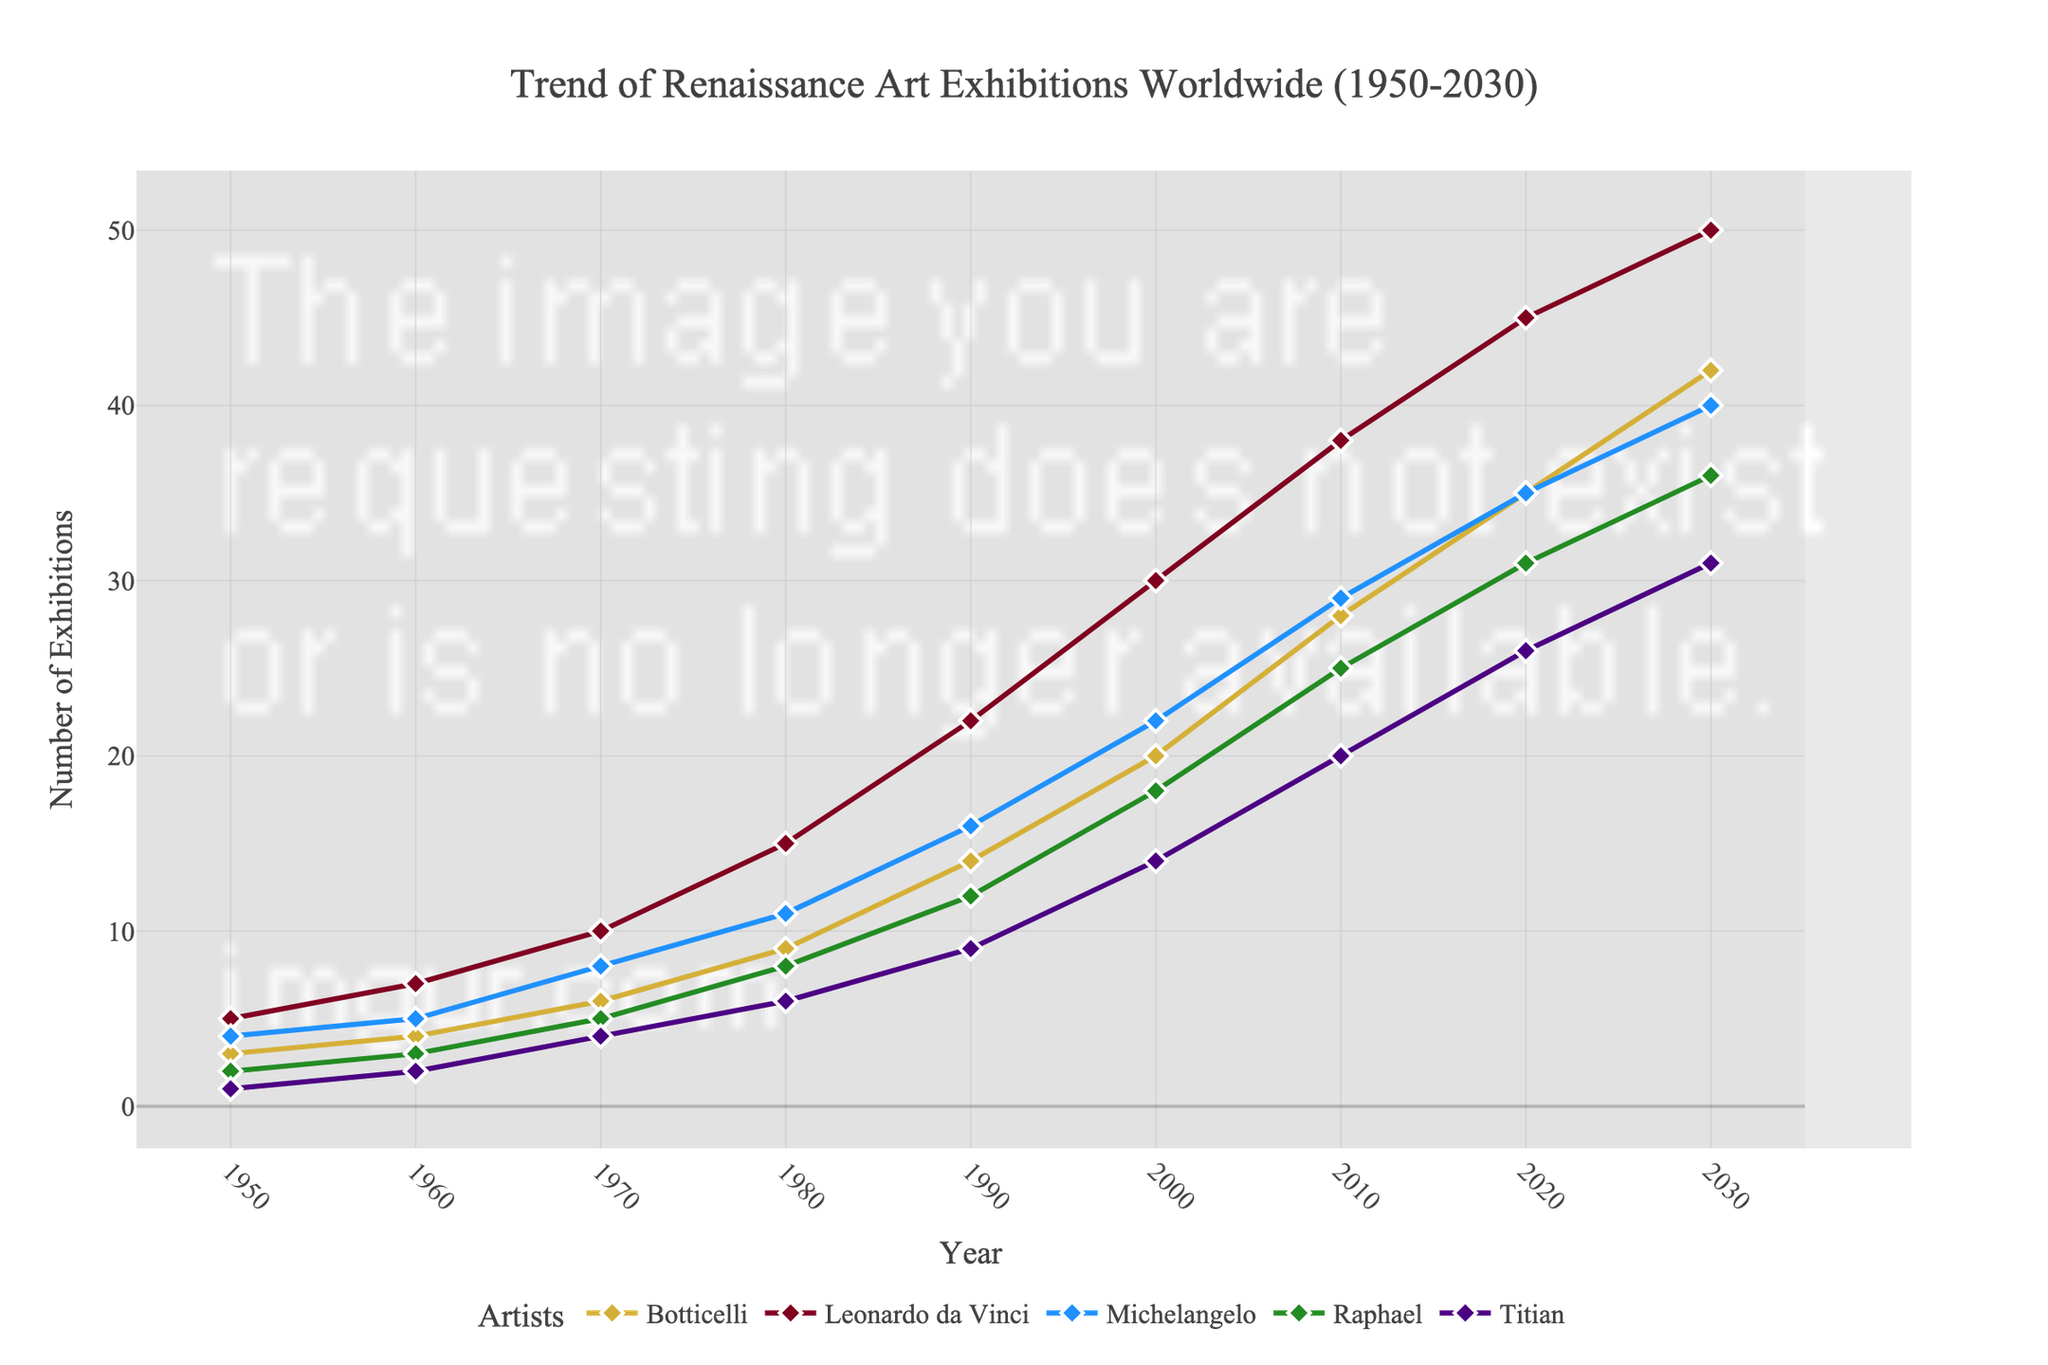what year did Botticelli have the most art exhibitions? The highest value for Botticelli is found in 2030, with 42 exhibitions.
Answer: 2030 How many exhibitions did Leonardo da Vinci have in 1980? The number of exhibitions for Leonardo da Vinci in 1980 is listed as 15.
Answer: 15 Which artist had the fewest exhibitions in 1950? The artist with the lowest value in 1950 is Titian, with 1 exhibition.
Answer: Titian Between 2000 and 2020, which artist saw the greatest increase in the number of exhibitions? Leonardo da Vinci had the highest increase of 15 exhibitions (from 30 in 2000 to 45 in 2020).
Answer: Leonardo da Vinci How many total exhibitions did Michelangelo have from 1950 to 2030? Summing up the values for Michelangelo gives 4+5+8+11+16+22+29+35+40 = 170 exhibitions.
Answer: 170 By what percentage did the number of Raphael exhibitions increase from 1990 to 2030? The increase is 36 - 12 = 24, which is an increase of (24 / 12) * 100 = 200%.
Answer: 200% Which artist had the closest number of exhibitions to 20 in the year 2000? The closest number to 20 in 2000 is Titian with 14 exhibitions.
Answer: Titian What is the total number of exhibitions for all artists combined in 1960? Summing up the values: 4 + 7 + 5 + 3 + 2 = 21 exhibitions.
Answer: 21 Which artist showed the least change in the number of exhibitions from 1990 to 2010? The least change is in Botticelli, with an increase of 14 (from 14 in 1990 to 28 in 2010).
Answer: Botticelli Are there any years where the number of Botticelli and Raphael exhibitions are equal? In 2030, both Botticelli and Raphael had 42 and 36 exhibitions respectively, which are not equal. No such years exist.
Answer: No 